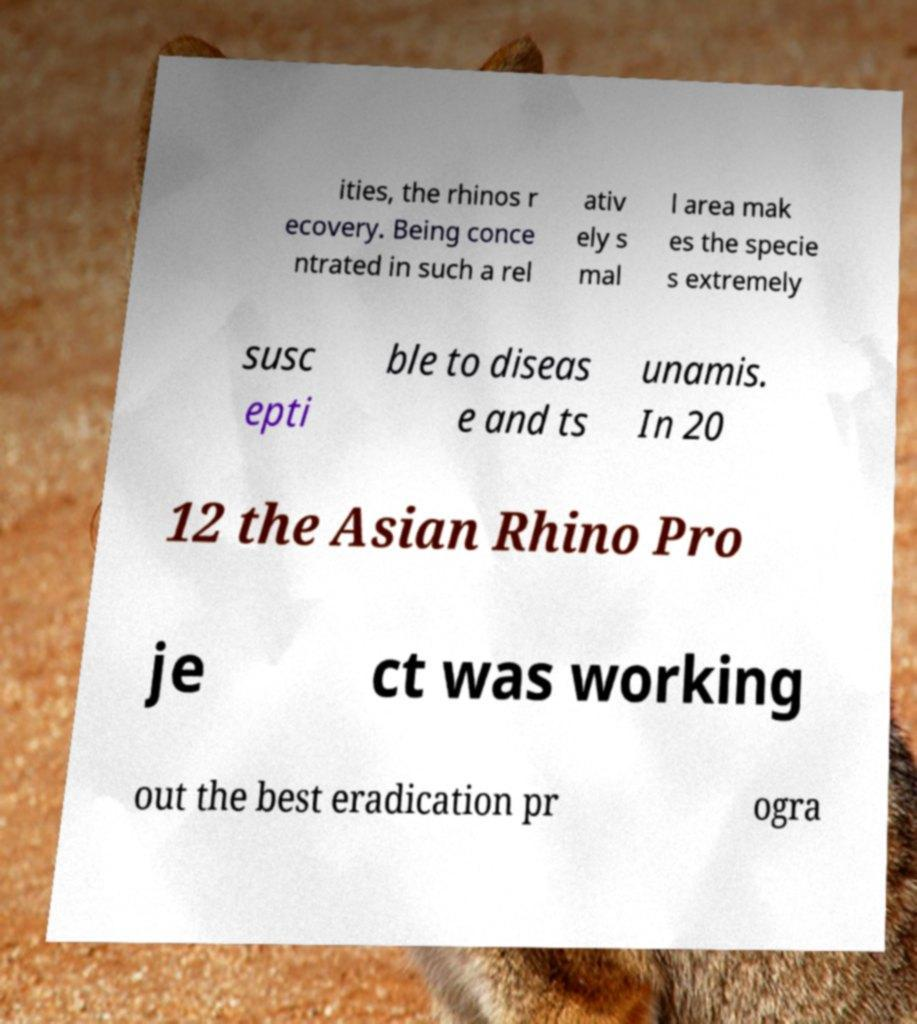For documentation purposes, I need the text within this image transcribed. Could you provide that? ities, the rhinos r ecovery. Being conce ntrated in such a rel ativ ely s mal l area mak es the specie s extremely susc epti ble to diseas e and ts unamis. In 20 12 the Asian Rhino Pro je ct was working out the best eradication pr ogra 